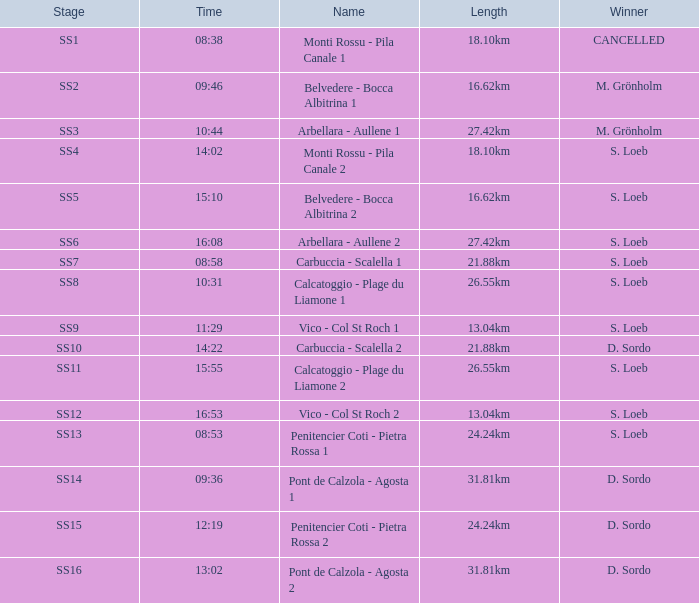What is the title of the ss11 stage? Calcatoggio - Plage du Liamone 2. 